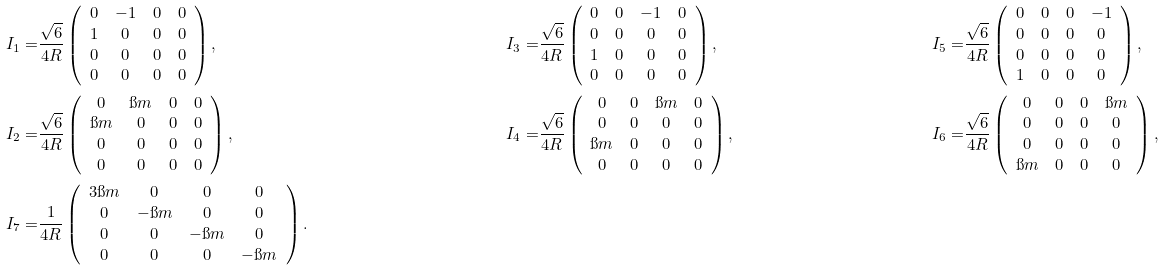<formula> <loc_0><loc_0><loc_500><loc_500>I _ { 1 } = & \frac { \sqrt { 6 } } { 4 R } \left ( \begin{array} { c c c c } 0 & - 1 & 0 & 0 \\ 1 & 0 & 0 & 0 \\ 0 & 0 & 0 & 0 \\ 0 & 0 & 0 & 0 \end{array} \right ) , & I _ { 3 } = & \frac { \sqrt { 6 } } { 4 R } \left ( \begin{array} { c c c c } 0 & 0 & - 1 & 0 \\ 0 & 0 & 0 & 0 \\ 1 & 0 & 0 & 0 \\ 0 & 0 & 0 & 0 \end{array} \right ) , & I _ { 5 } = & \frac { \sqrt { 6 } } { 4 R } \left ( \begin{array} { c c c c } 0 & 0 & 0 & - 1 \\ 0 & 0 & 0 & 0 \\ 0 & 0 & 0 & 0 \\ 1 & 0 & 0 & 0 \end{array} \right ) , \\ I _ { 2 } = & \frac { \sqrt { 6 } } { 4 R } \left ( \begin{array} { c c c c } 0 & \i m & 0 & 0 \\ \i m & 0 & 0 & 0 \\ 0 & 0 & 0 & 0 \\ 0 & 0 & 0 & 0 \end{array} \right ) , & I _ { 4 } = & \frac { \sqrt { 6 } } { 4 R } \left ( \begin{array} { c c c c } 0 & 0 & \i m & 0 \\ 0 & 0 & 0 & 0 \\ \i m & 0 & 0 & 0 \\ 0 & 0 & 0 & 0 \end{array} \right ) , & I _ { 6 } = & \frac { \sqrt { 6 } } { 4 R } \left ( \begin{array} { c c c c } 0 & 0 & 0 & \i m \\ 0 & 0 & 0 & 0 \\ 0 & 0 & 0 & 0 \\ \i m & 0 & 0 & 0 \end{array} \right ) , \\ I _ { 7 } = & \frac { 1 } { 4 R } \left ( \begin{array} { c c c c } 3 \i m & 0 & 0 & 0 \\ 0 & - \i m & 0 & 0 \\ 0 & 0 & - \i m & 0 \\ 0 & 0 & 0 & - \i m \end{array} \right ) .</formula> 